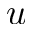Convert formula to latex. <formula><loc_0><loc_0><loc_500><loc_500>u</formula> 